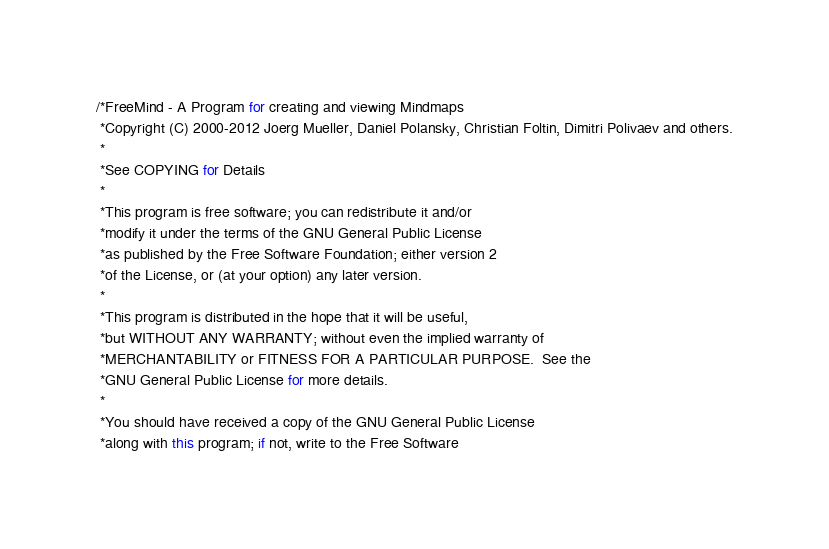<code> <loc_0><loc_0><loc_500><loc_500><_Java_>/*FreeMind - A Program for creating and viewing Mindmaps
 *Copyright (C) 2000-2012 Joerg Mueller, Daniel Polansky, Christian Foltin, Dimitri Polivaev and others.
 *
 *See COPYING for Details
 *
 *This program is free software; you can redistribute it and/or
 *modify it under the terms of the GNU General Public License
 *as published by the Free Software Foundation; either version 2
 *of the License, or (at your option) any later version.
 *
 *This program is distributed in the hope that it will be useful,
 *but WITHOUT ANY WARRANTY; without even the implied warranty of
 *MERCHANTABILITY or FITNESS FOR A PARTICULAR PURPOSE.  See the
 *GNU General Public License for more details.
 *
 *You should have received a copy of the GNU General Public License
 *along with this program; if not, write to the Free Software</code> 